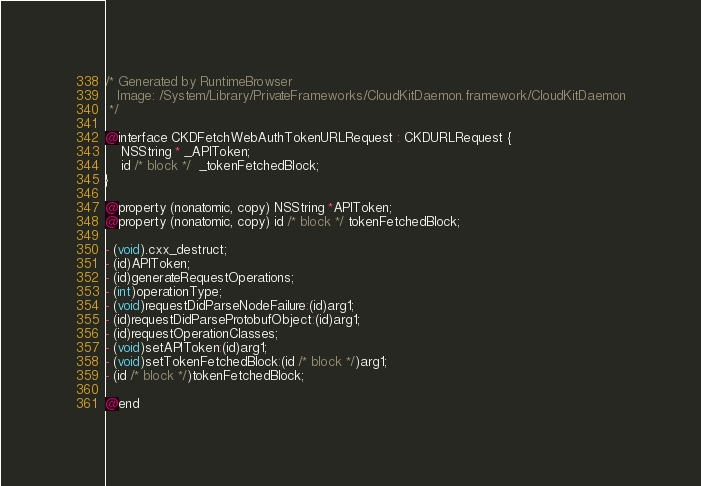<code> <loc_0><loc_0><loc_500><loc_500><_C_>/* Generated by RuntimeBrowser
   Image: /System/Library/PrivateFrameworks/CloudKitDaemon.framework/CloudKitDaemon
 */

@interface CKDFetchWebAuthTokenURLRequest : CKDURLRequest {
    NSString * _APIToken;
    id /* block */  _tokenFetchedBlock;
}

@property (nonatomic, copy) NSString *APIToken;
@property (nonatomic, copy) id /* block */ tokenFetchedBlock;

- (void).cxx_destruct;
- (id)APIToken;
- (id)generateRequestOperations;
- (int)operationType;
- (void)requestDidParseNodeFailure:(id)arg1;
- (id)requestDidParseProtobufObject:(id)arg1;
- (id)requestOperationClasses;
- (void)setAPIToken:(id)arg1;
- (void)setTokenFetchedBlock:(id /* block */)arg1;
- (id /* block */)tokenFetchedBlock;

@end
</code> 